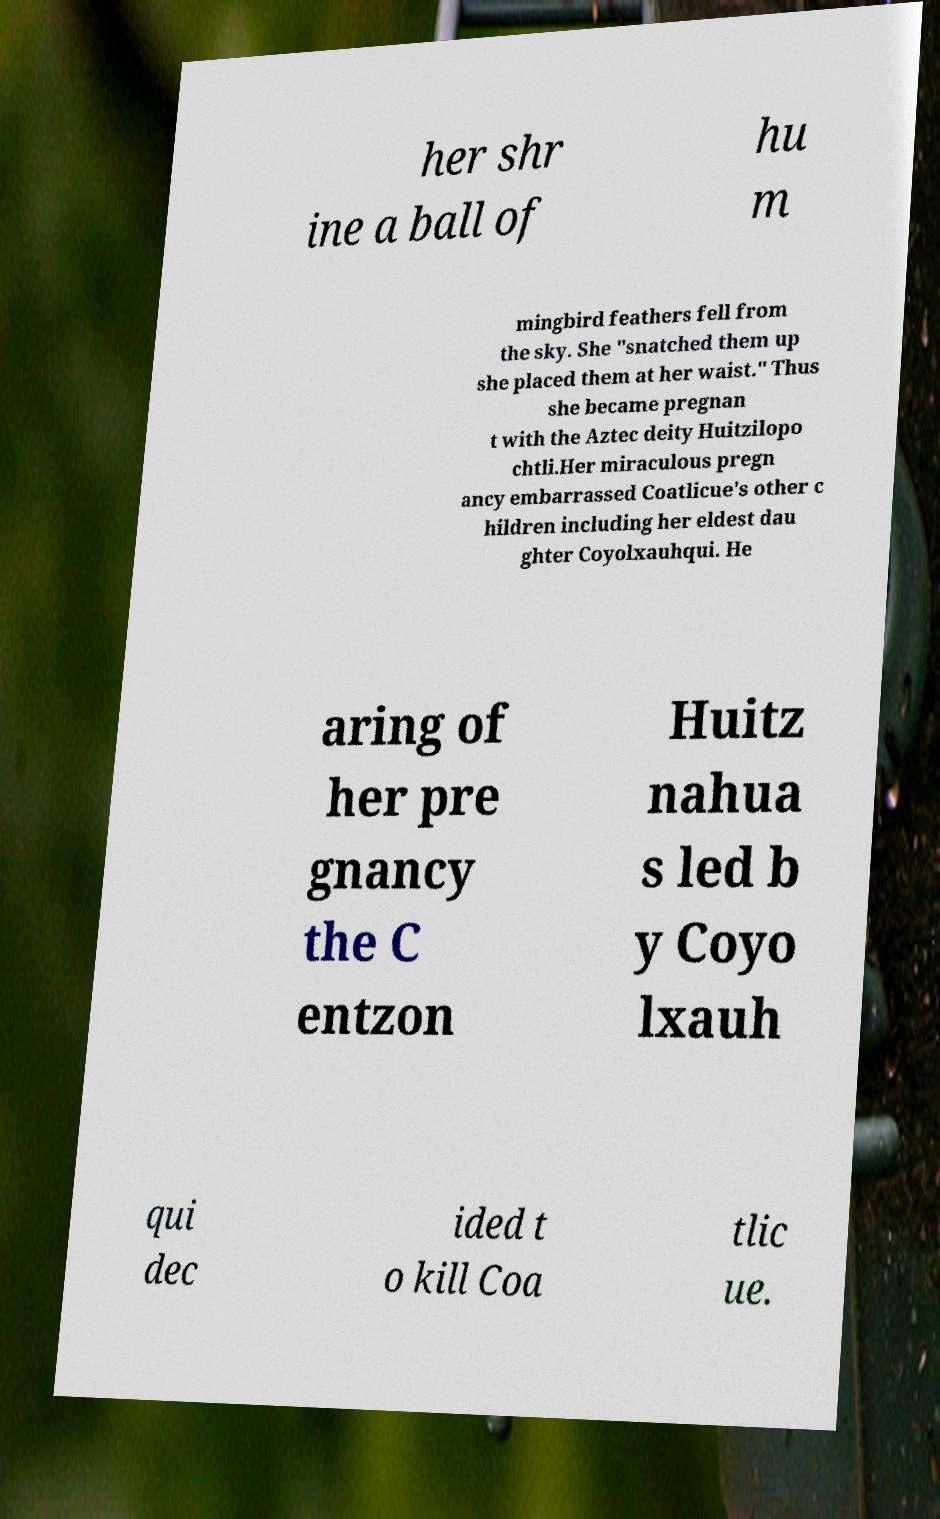Can you accurately transcribe the text from the provided image for me? her shr ine a ball of hu m mingbird feathers fell from the sky. She "snatched them up she placed them at her waist." Thus she became pregnan t with the Aztec deity Huitzilopo chtli.Her miraculous pregn ancy embarrassed Coatlicue's other c hildren including her eldest dau ghter Coyolxauhqui. He aring of her pre gnancy the C entzon Huitz nahua s led b y Coyo lxauh qui dec ided t o kill Coa tlic ue. 